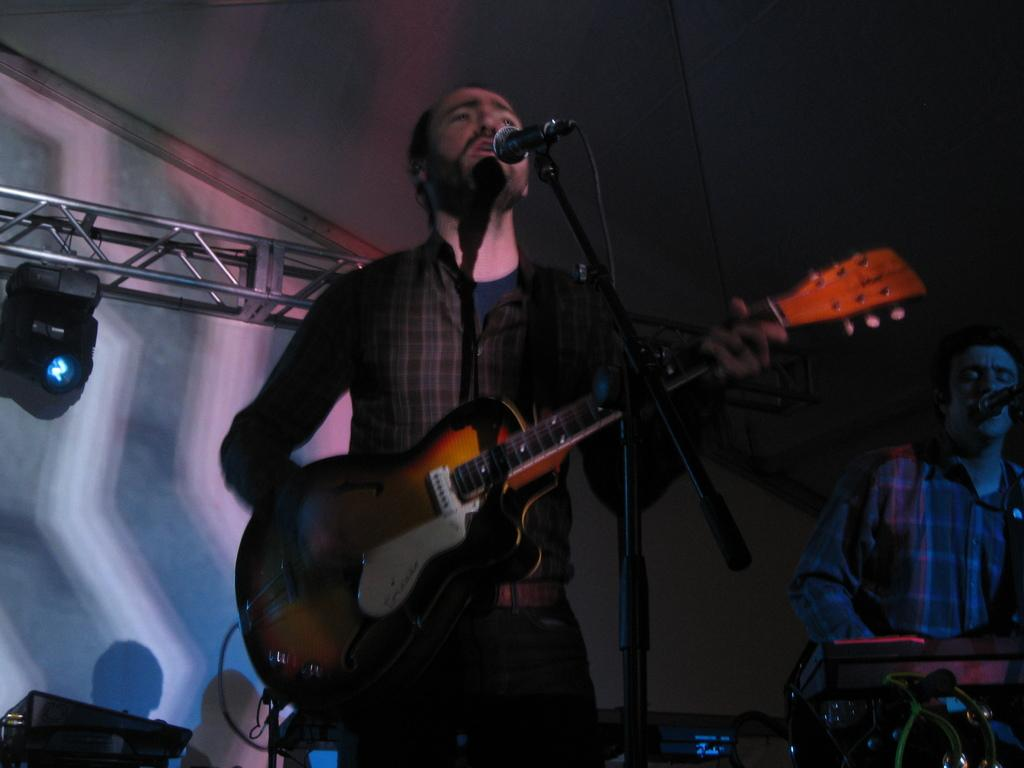What is the person standing and singing doing with their hands? The person is holding a guitar in their hands. What equipment is in front of the person singing? There is a microphone and stand in front of the person. What other musical instrument is being played in the image? There is a person playing piano and singing. What type of science experiment is being conducted in the image? There is no science experiment present in the image; it features people singing and playing musical instruments. How many houses are visible in the image? There are no houses visible in the image. 